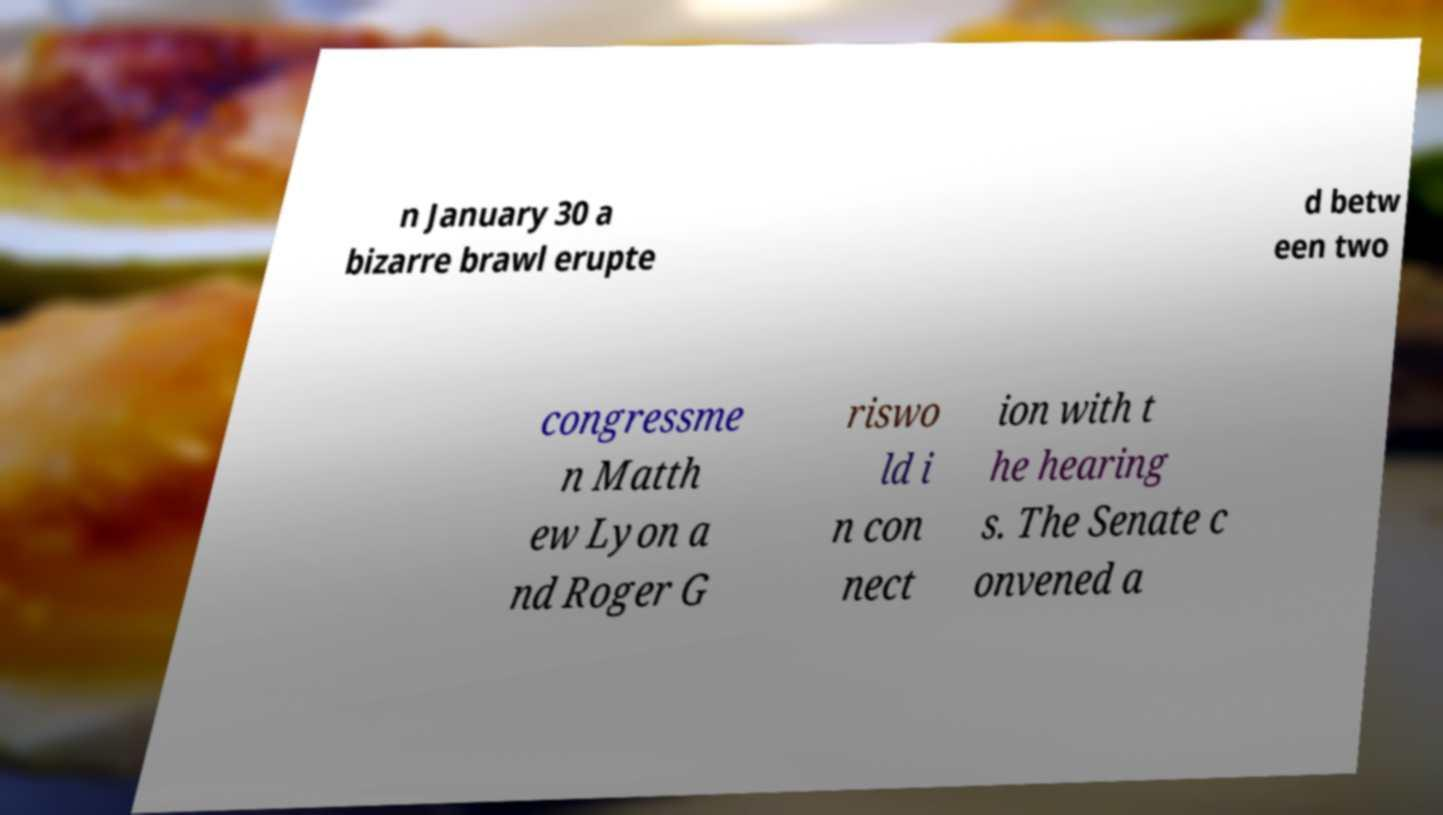There's text embedded in this image that I need extracted. Can you transcribe it verbatim? n January 30 a bizarre brawl erupte d betw een two congressme n Matth ew Lyon a nd Roger G riswo ld i n con nect ion with t he hearing s. The Senate c onvened a 